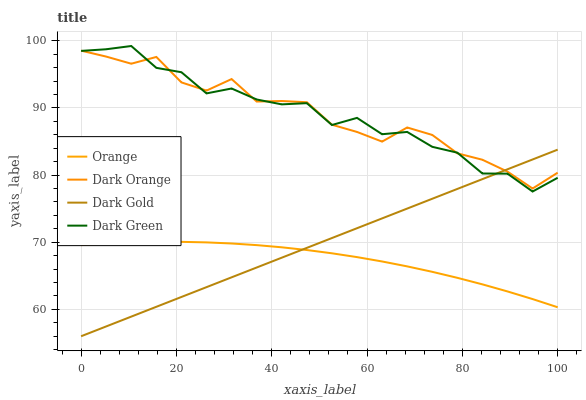Does Orange have the minimum area under the curve?
Answer yes or no. Yes. Does Dark Orange have the maximum area under the curve?
Answer yes or no. Yes. Does Dark Green have the minimum area under the curve?
Answer yes or no. No. Does Dark Green have the maximum area under the curve?
Answer yes or no. No. Is Dark Gold the smoothest?
Answer yes or no. Yes. Is Dark Green the roughest?
Answer yes or no. Yes. Is Dark Orange the smoothest?
Answer yes or no. No. Is Dark Orange the roughest?
Answer yes or no. No. Does Dark Gold have the lowest value?
Answer yes or no. Yes. Does Dark Green have the lowest value?
Answer yes or no. No. Does Dark Green have the highest value?
Answer yes or no. Yes. Does Dark Orange have the highest value?
Answer yes or no. No. Is Orange less than Dark Green?
Answer yes or no. Yes. Is Dark Green greater than Orange?
Answer yes or no. Yes. Does Orange intersect Dark Gold?
Answer yes or no. Yes. Is Orange less than Dark Gold?
Answer yes or no. No. Is Orange greater than Dark Gold?
Answer yes or no. No. Does Orange intersect Dark Green?
Answer yes or no. No. 